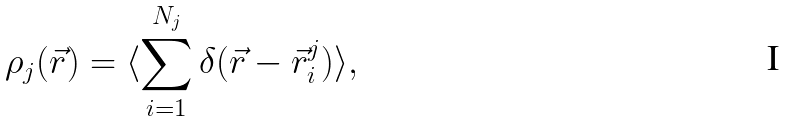<formula> <loc_0><loc_0><loc_500><loc_500>\rho _ { j } ( { \vec { r } } ) = \langle \sum _ { i = 1 } ^ { N _ { j } } \delta ( { \vec { r } } - \vec { r } _ { i } ^ { j } ) \rangle ,</formula> 